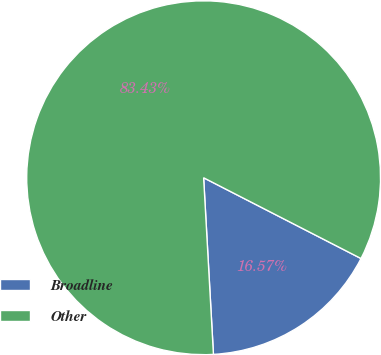Convert chart to OTSL. <chart><loc_0><loc_0><loc_500><loc_500><pie_chart><fcel>Broadline<fcel>Other<nl><fcel>16.57%<fcel>83.43%<nl></chart> 